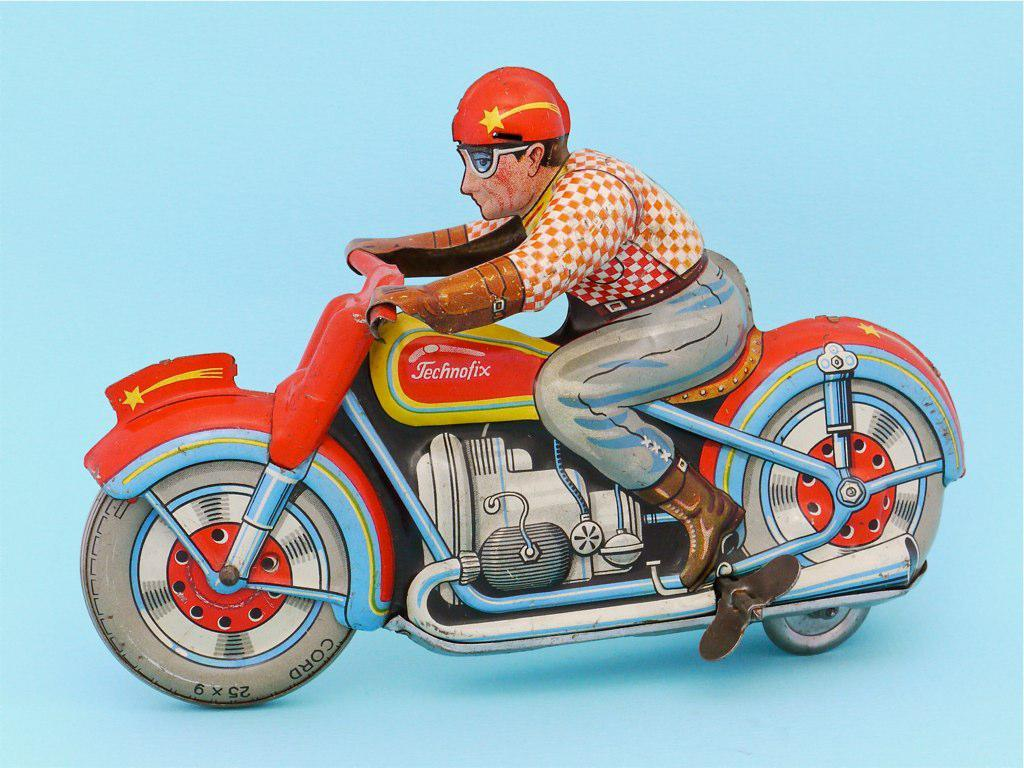What type of drawing is featured in the image? The image contains a 3D drawing. What is the subject of the 3D drawing? The drawing depicts a person riding a motorbike. Is the person wearing a mask while riding the motorbike in the image? There is no mention of a mask in the image, as it only features a person riding a motorbike in a 3D drawing. 